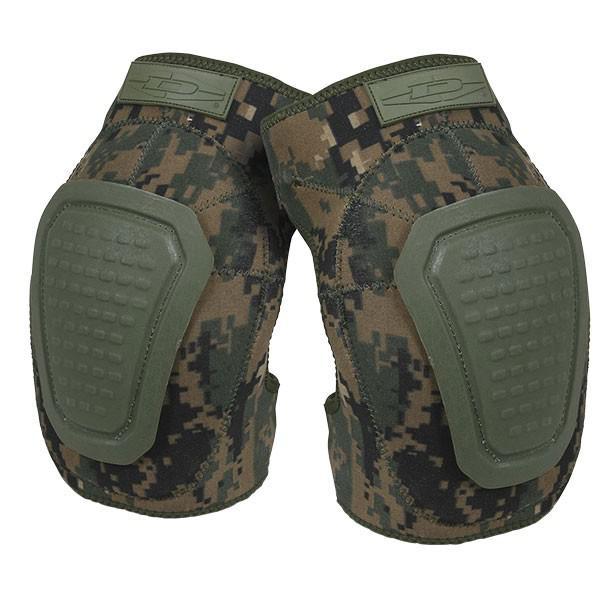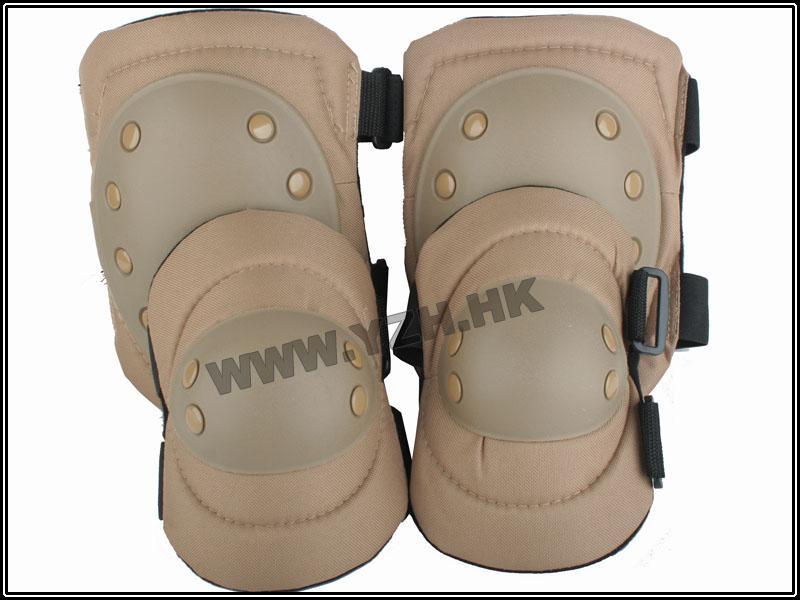The first image is the image on the left, the second image is the image on the right. Examine the images to the left and right. Is the description "At least one image shows a pair of kneepads with a camo pattern." accurate? Answer yes or no. Yes. The first image is the image on the left, the second image is the image on the right. Assess this claim about the two images: "There are camp patterned knee pads". Correct or not? Answer yes or no. Yes. 